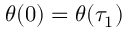<formula> <loc_0><loc_0><loc_500><loc_500>\theta ( 0 ) = \theta ( \tau _ { 1 } )</formula> 